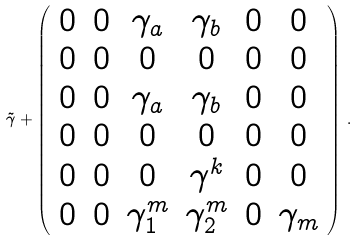Convert formula to latex. <formula><loc_0><loc_0><loc_500><loc_500>\tilde { \gamma } + \left ( \begin{array} { c c c c c c } 0 & 0 & \gamma _ { a } & \gamma _ { b } & 0 & 0 \\ 0 & 0 & 0 & 0 & 0 & 0 \\ 0 & 0 & \gamma _ { a } & \gamma _ { b } & 0 & 0 \\ 0 & 0 & 0 & 0 & 0 & 0 \\ 0 & 0 & 0 & \gamma ^ { k } & 0 & 0 \\ 0 & 0 & \gamma ^ { m } _ { 1 } & \gamma ^ { m } _ { 2 } & 0 & \gamma _ { m } \end{array} \right ) \, .</formula> 